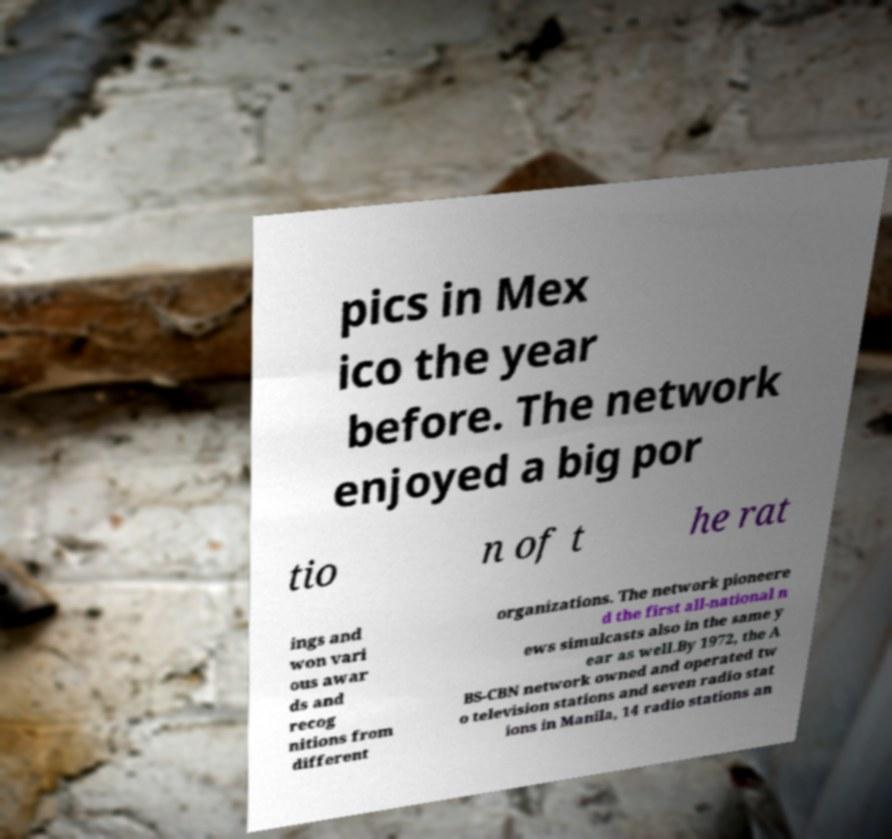Please read and relay the text visible in this image. What does it say? pics in Mex ico the year before. The network enjoyed a big por tio n of t he rat ings and won vari ous awar ds and recog nitions from different organizations. The network pioneere d the first all-national n ews simulcasts also in the same y ear as well.By 1972, the A BS-CBN network owned and operated tw o television stations and seven radio stat ions in Manila, 14 radio stations an 